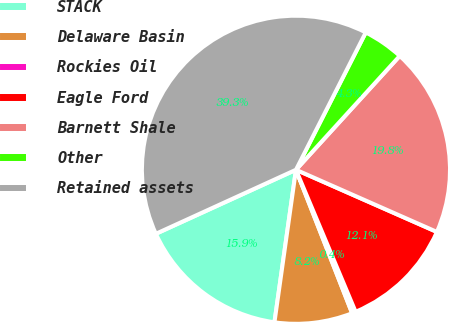Convert chart. <chart><loc_0><loc_0><loc_500><loc_500><pie_chart><fcel>STACK<fcel>Delaware Basin<fcel>Rockies Oil<fcel>Eagle Ford<fcel>Barnett Shale<fcel>Other<fcel>Retained assets<nl><fcel>15.95%<fcel>8.17%<fcel>0.39%<fcel>12.06%<fcel>19.85%<fcel>4.28%<fcel>39.31%<nl></chart> 